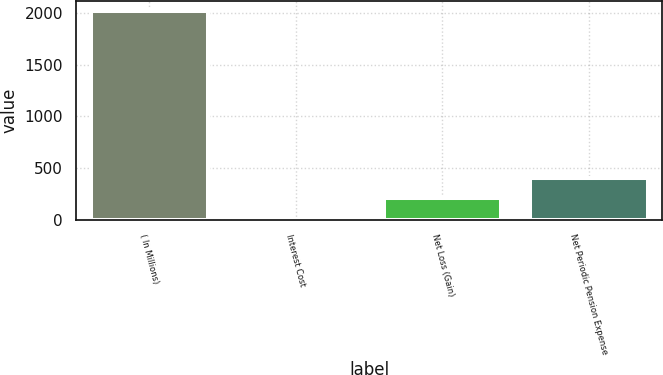Convert chart to OTSL. <chart><loc_0><loc_0><loc_500><loc_500><bar_chart><fcel>( In Millions)<fcel>Interest Cost<fcel>Net Loss (Gain)<fcel>Net Periodic Pension Expense<nl><fcel>2013<fcel>4.4<fcel>205.26<fcel>406.12<nl></chart> 